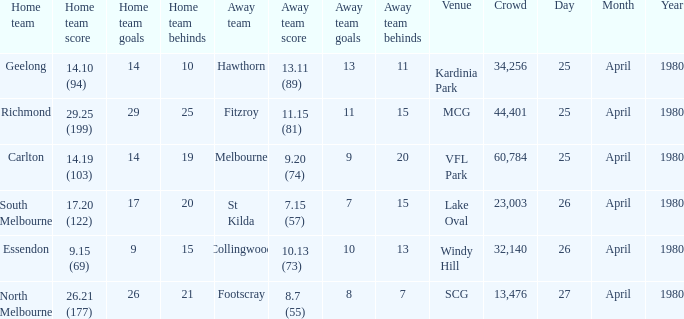What wa the date of the North Melbourne home game? 27 April 1980. 